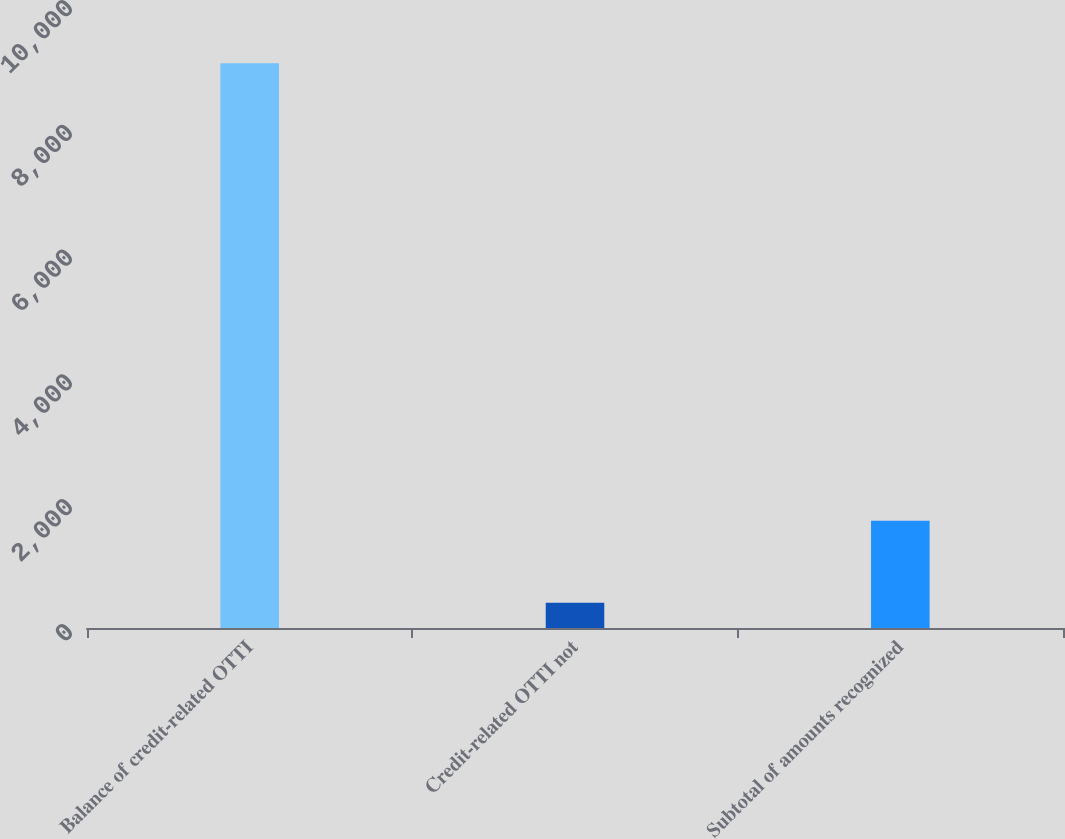Convert chart. <chart><loc_0><loc_0><loc_500><loc_500><bar_chart><fcel>Balance of credit-related OTTI<fcel>Credit-related OTTI not<fcel>Subtotal of amounts recognized<nl><fcel>9052<fcel>403<fcel>1717.6<nl></chart> 